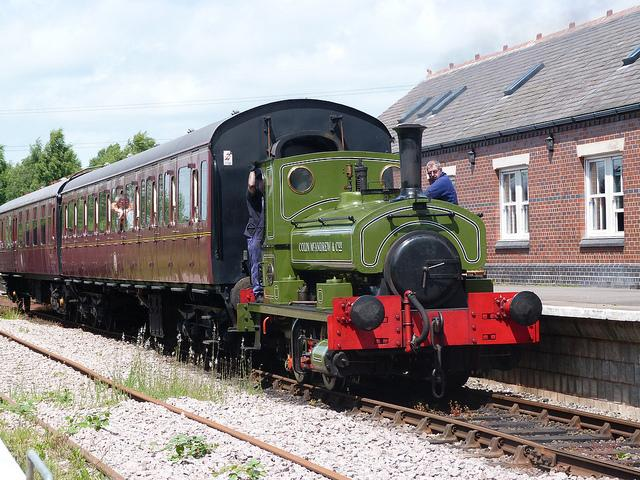What years was this machine first introduced? Please explain your reasoning. 1804. The year was 1804. 